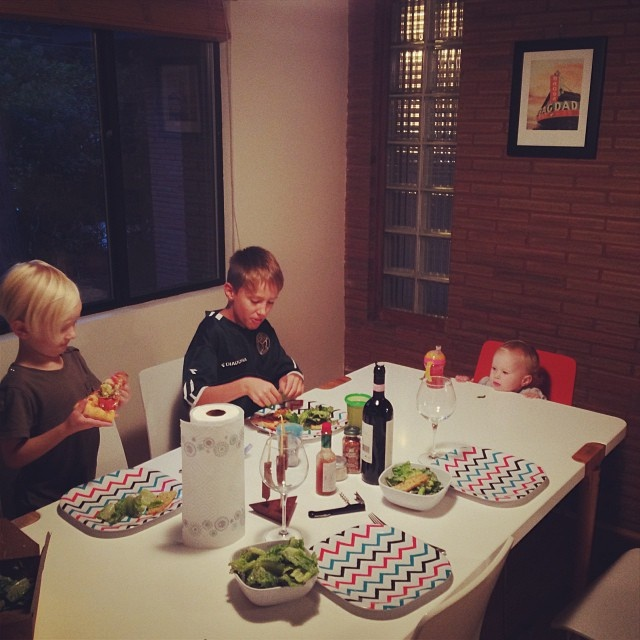Describe the objects in this image and their specific colors. I can see dining table in black and tan tones, people in black, maroon, brown, and tan tones, people in black, brown, maroon, and salmon tones, chair in black, brown, and maroon tones, and bowl in black, olive, and gray tones in this image. 